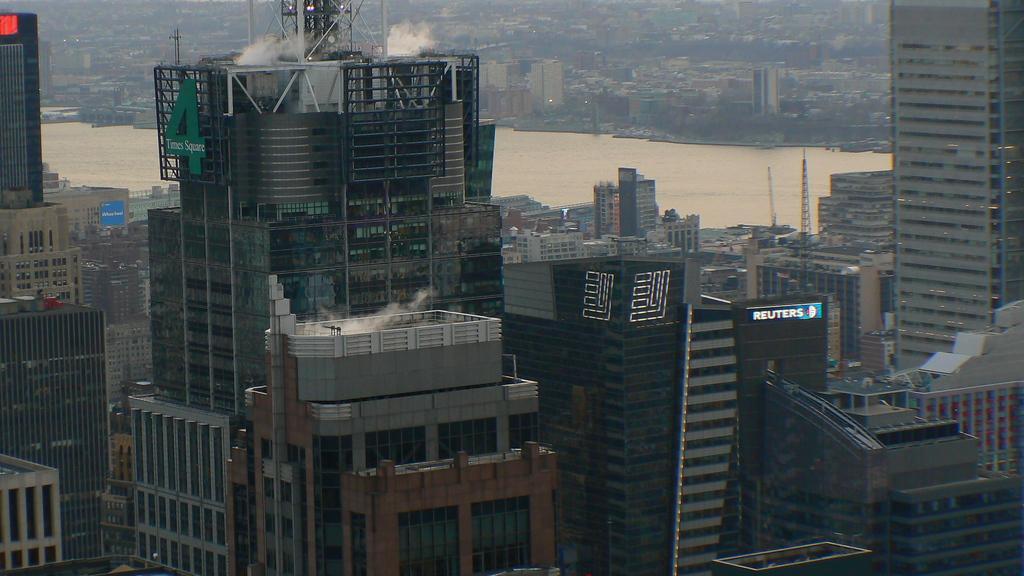Describe this image in one or two sentences. In this picture I can observe buildings. There is a river flowing behind these buildings. I can observe some smoke on the top of the picture. 